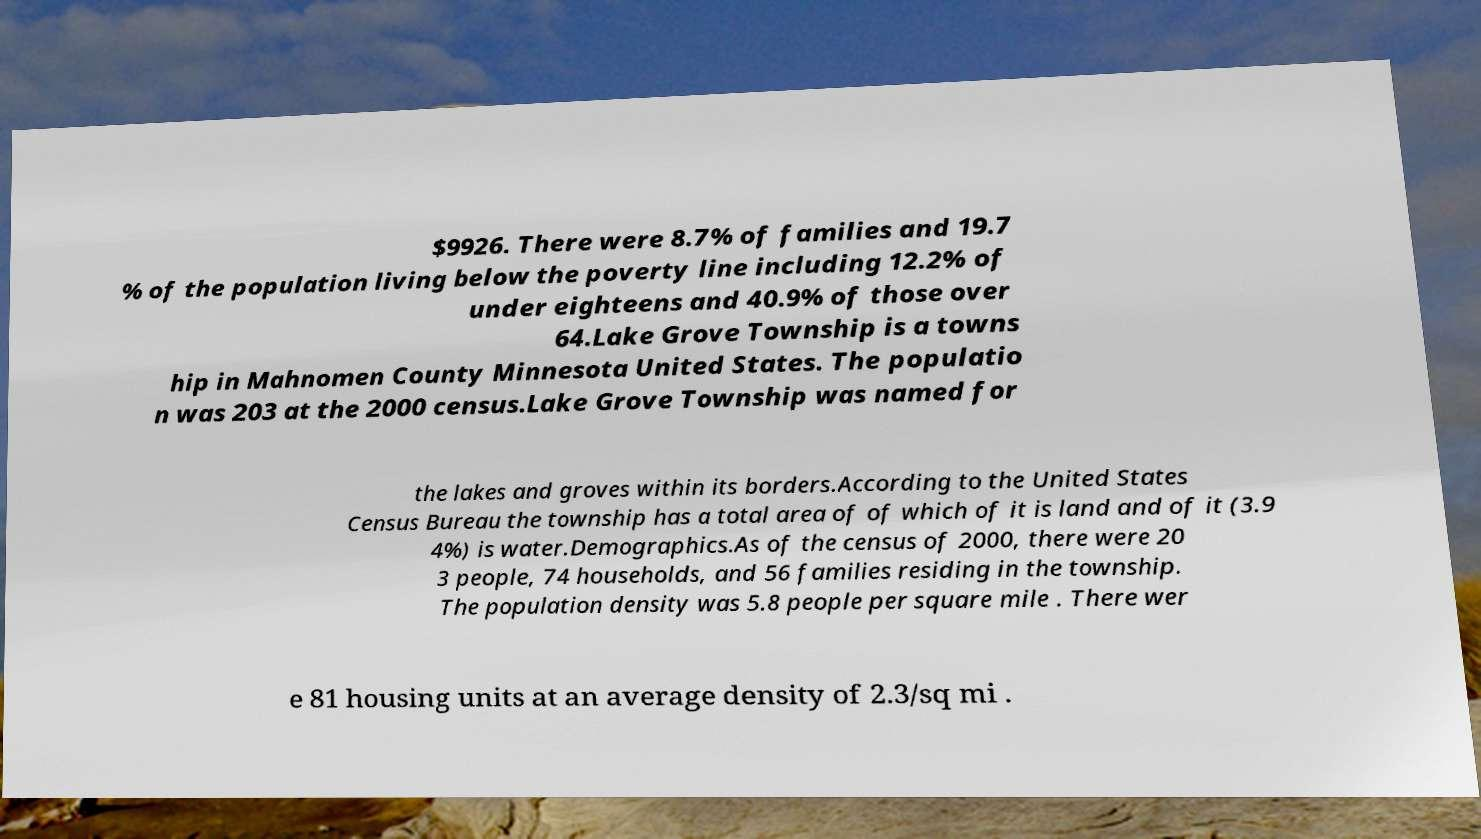Could you assist in decoding the text presented in this image and type it out clearly? $9926. There were 8.7% of families and 19.7 % of the population living below the poverty line including 12.2% of under eighteens and 40.9% of those over 64.Lake Grove Township is a towns hip in Mahnomen County Minnesota United States. The populatio n was 203 at the 2000 census.Lake Grove Township was named for the lakes and groves within its borders.According to the United States Census Bureau the township has a total area of of which of it is land and of it (3.9 4%) is water.Demographics.As of the census of 2000, there were 20 3 people, 74 households, and 56 families residing in the township. The population density was 5.8 people per square mile . There wer e 81 housing units at an average density of 2.3/sq mi . 